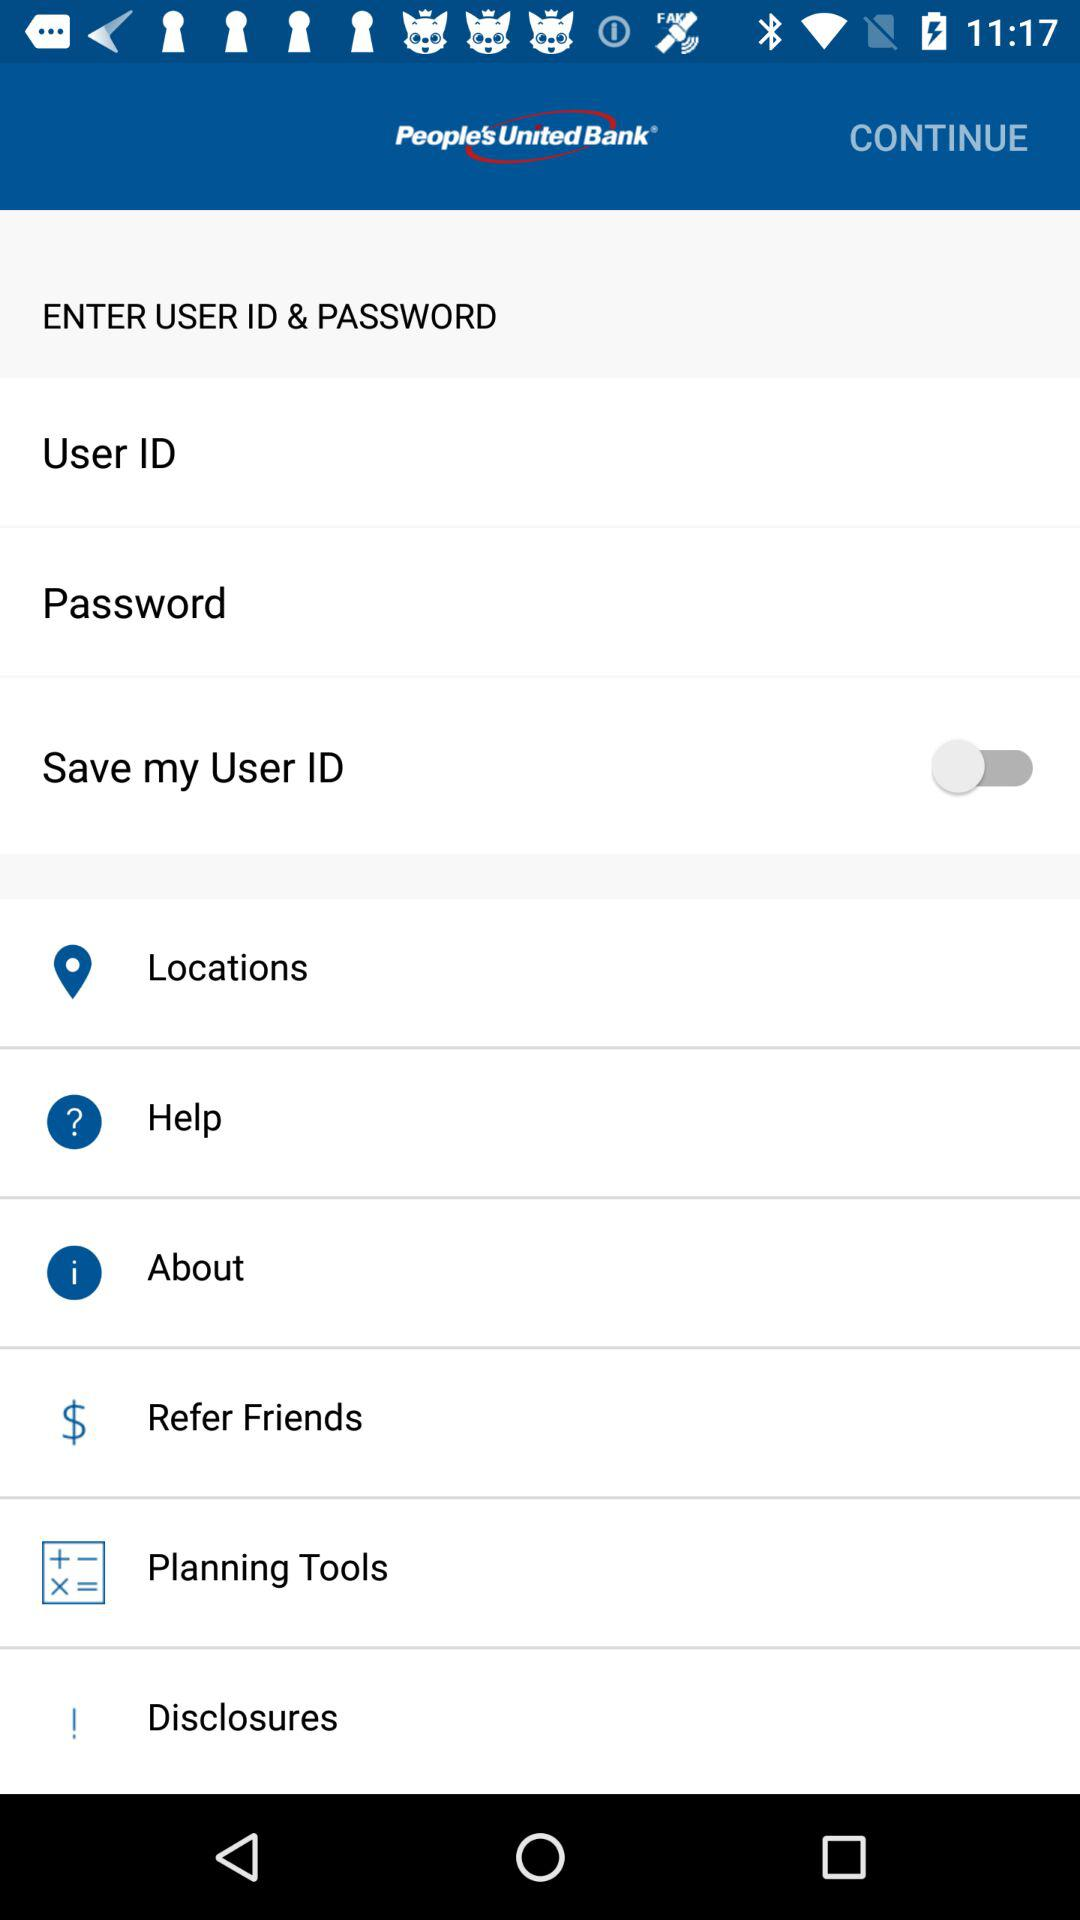What is the status of the "Save my user ID"? The status is "off". 